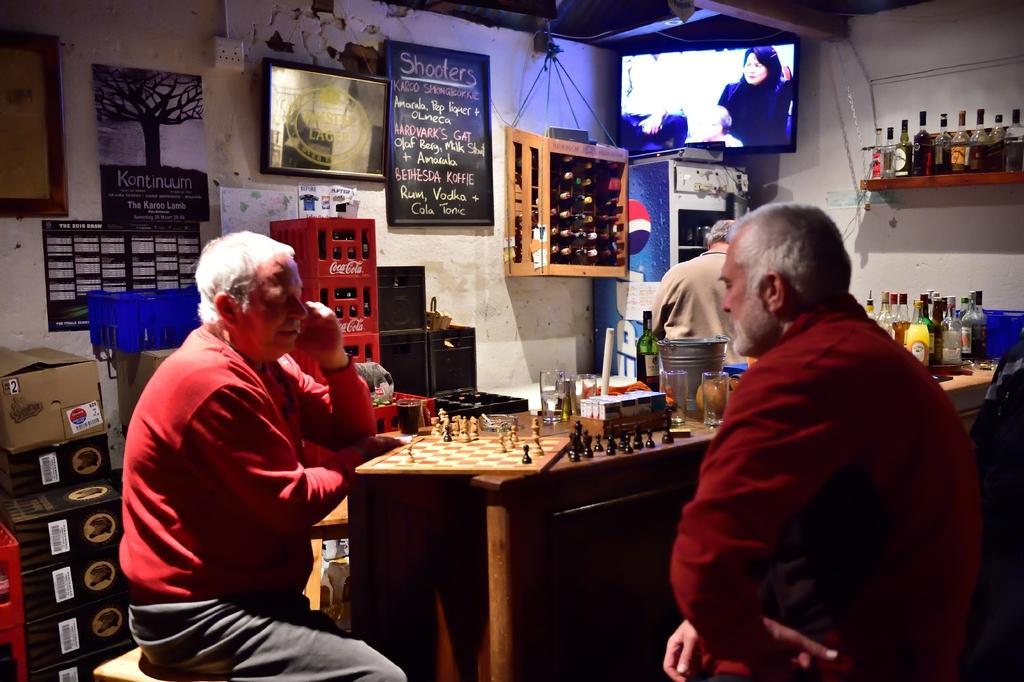Can you describe this image briefly? In this image I can see few persons are sitting on chairs in front of the table. On the table I can see a chess board, few chess pieces, few glasses, few bottles and few other objects. I can see a person standing, a refrigerator, the wall, few frames attached to the wall, few racks with bottles in them and a television. 